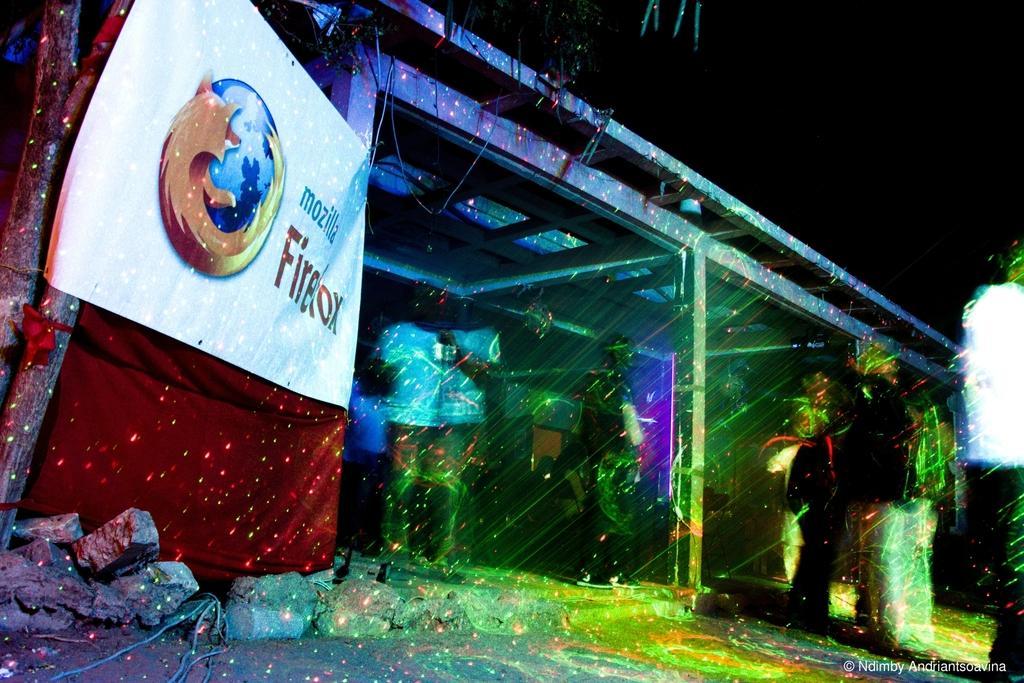How would you summarize this image in a sentence or two? In this image I can see the edited picture. I can see a banner which is white, orange and blue in color, few rocks on the ground, few persons standing on the ground, a tree, a building and the dark sky in the background. 